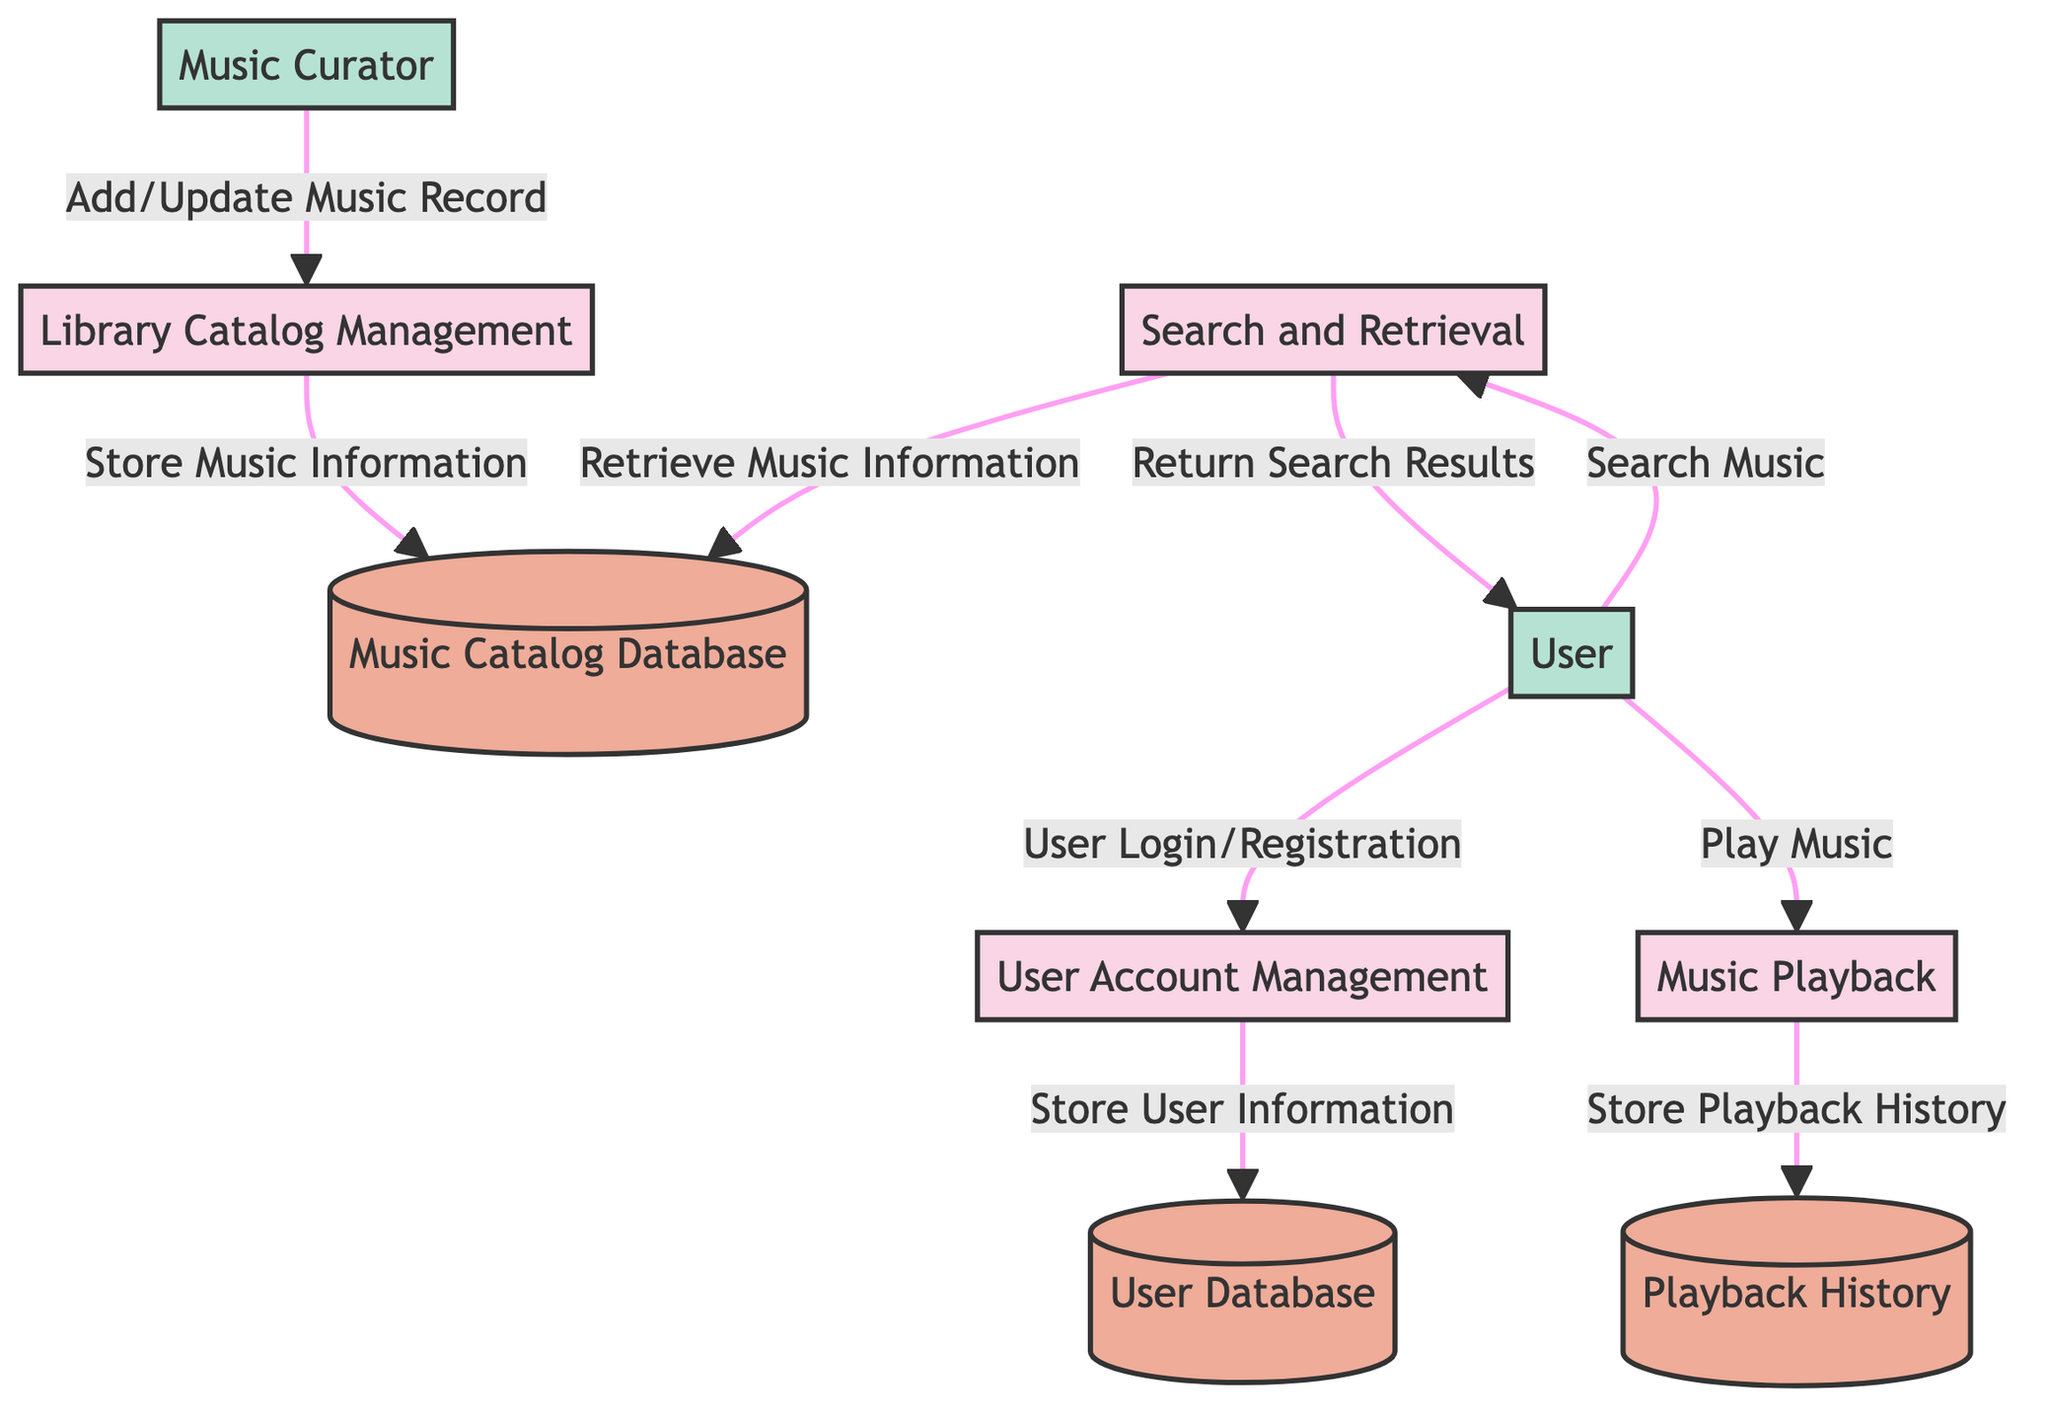What processes are included in the diagram? The diagram includes four processes: User Account Management, Library Catalog Management, Search and Retrieval, and Music Playback. These can be identified by the labeled boxes representing processes.
Answer: User Account Management, Library Catalog Management, Search and Retrieval, Music Playback How many data stores are present in the diagram? There are three data stores represented in the diagram, which are the User Database, Music Catalog Database, and Playback History. Each data store is indicated by a distinct labeled shape in the diagram.
Answer: 3 Which external entity interacts with the User Account Management process? The User external entity interacts with the User Account Management process by sending the data flow labeled User Login/Registration. This connection can be seen as an arrow leading into the process from the User entity.
Answer: User What information does the Library Catalog Management process store? The Library Catalog Management process stores Music Information, which is indicated by the labeled arrow going from the process to the Music Catalog Database data store.
Answer: Music Information What is the purpose of the data flow named 'Return Search Results'? The 'Return Search Results' data flow is responsible for sending the search results back to the User after the Search and Retrieval process has been completed. This relationship can be traced through the arrows connecting these processes.
Answer: Send search results back How many interactions does the User external entity have with the system? The User external entity has three interactions with various processes in the system: User Login/Registration, Search Music, and Play Music. Each interaction can be traced to the different arrows leading from the User entity.
Answer: 3 Which process is responsible for storing Playback History? The Music Playback process is responsible for storing Playback History, as indicated by the data flow connecting it to the Playback History data store. The diagram shows the flow of data to this specific store.
Answer: Music Playback What does the Music Curator entity do in the diagram? The Music Curator entity adds or updates music records in the Library Catalog Management process, which is shown by the data flow named Add/Update Music Record directed towards that process.
Answer: Add/Update Music Record Describe the relationship between the Search and Retrieval process and the Music Catalog Database. The relationship is that the Search and Retrieval process retrieves music information from the Music Catalog Database when a search is conducted. This can be identified through the arrow connecting the Search and Retrieval process to the Music Catalog Database.
Answer: Retrieve music information 